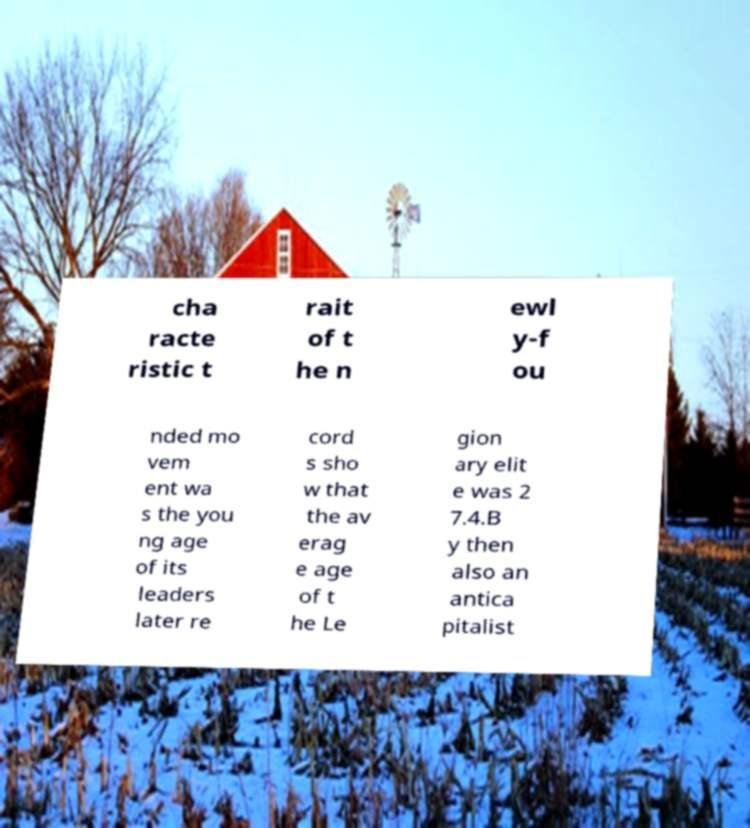Please read and relay the text visible in this image. What does it say? cha racte ristic t rait of t he n ewl y-f ou nded mo vem ent wa s the you ng age of its leaders later re cord s sho w that the av erag e age of t he Le gion ary elit e was 2 7.4.B y then also an antica pitalist 